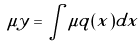Convert formula to latex. <formula><loc_0><loc_0><loc_500><loc_500>\mu y = \int \mu q ( x ) d x</formula> 